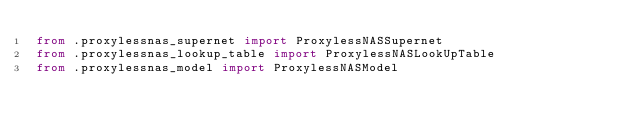Convert code to text. <code><loc_0><loc_0><loc_500><loc_500><_Python_>from .proxylessnas_supernet import ProxylessNASSupernet
from .proxylessnas_lookup_table import ProxylessNASLookUpTable
from .proxylessnas_model import ProxylessNASModel
</code> 